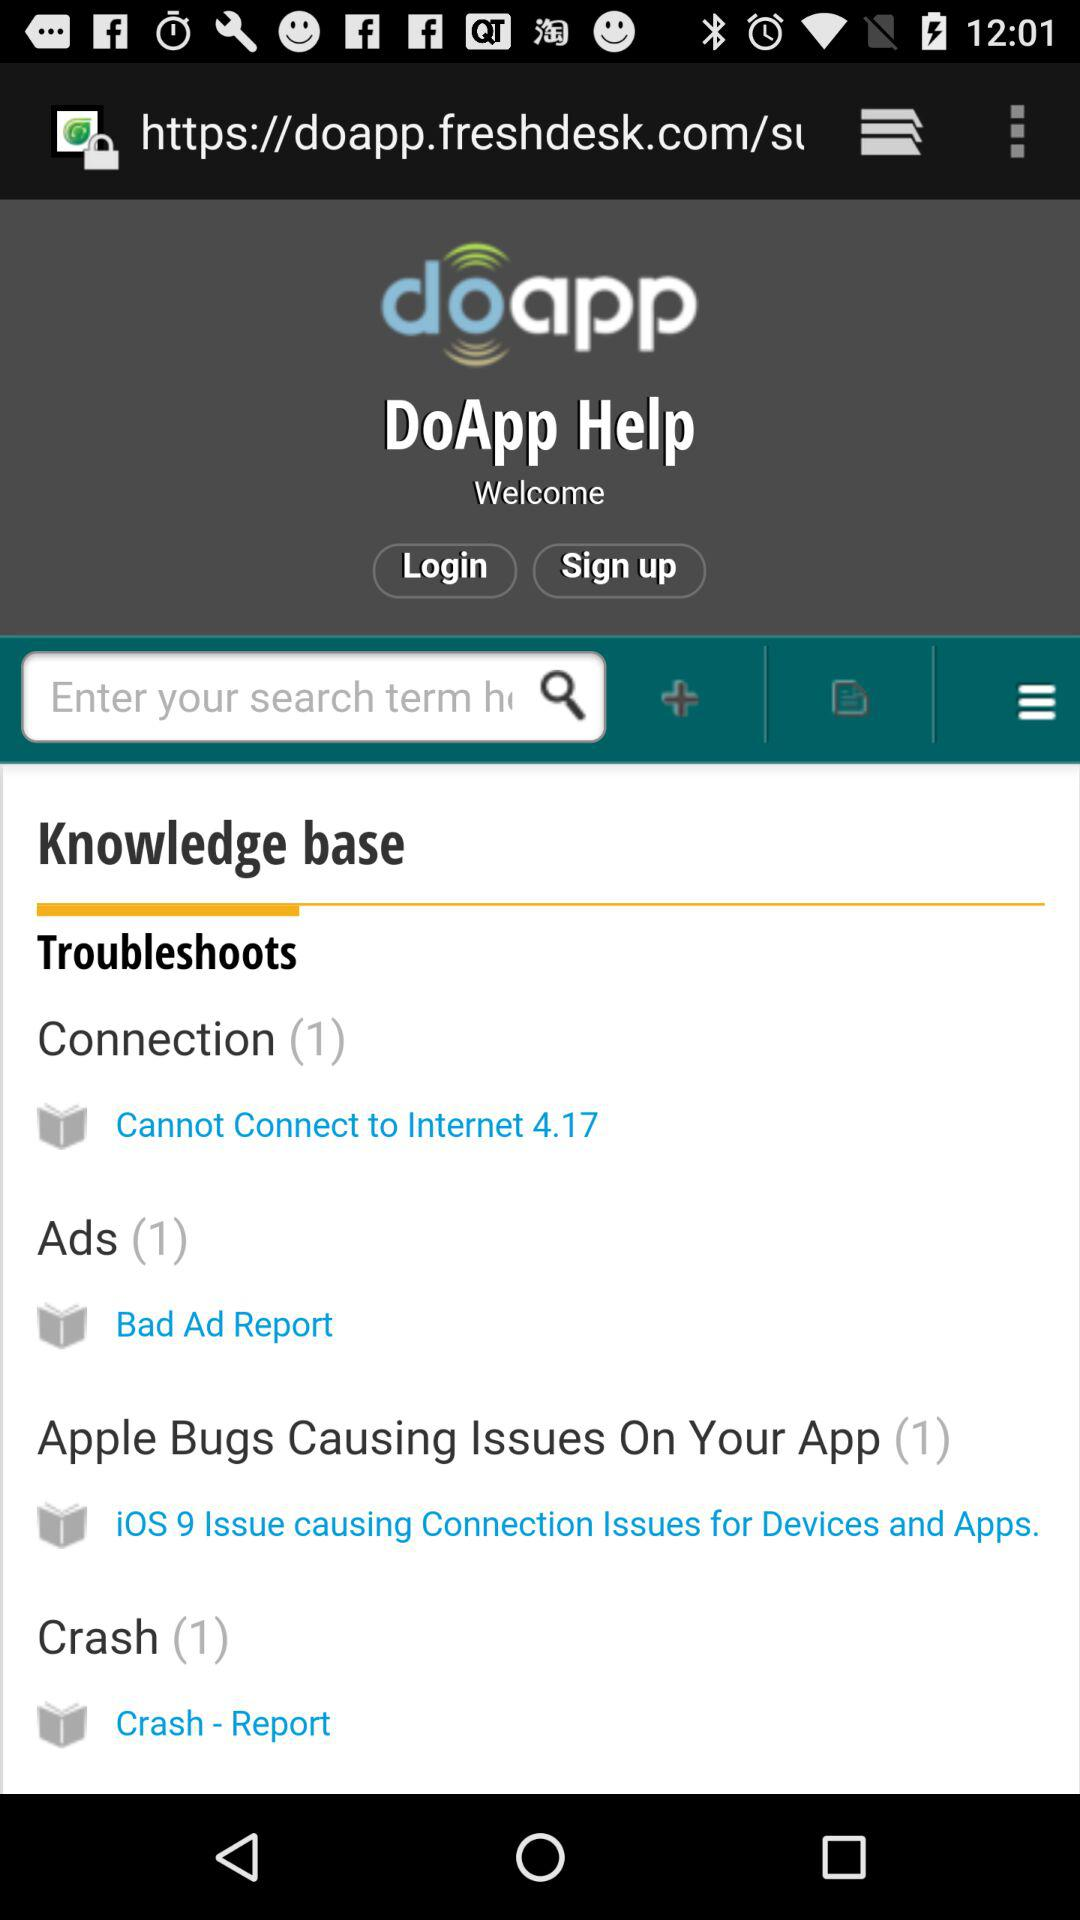How many connections are there? There is 1 connection. 